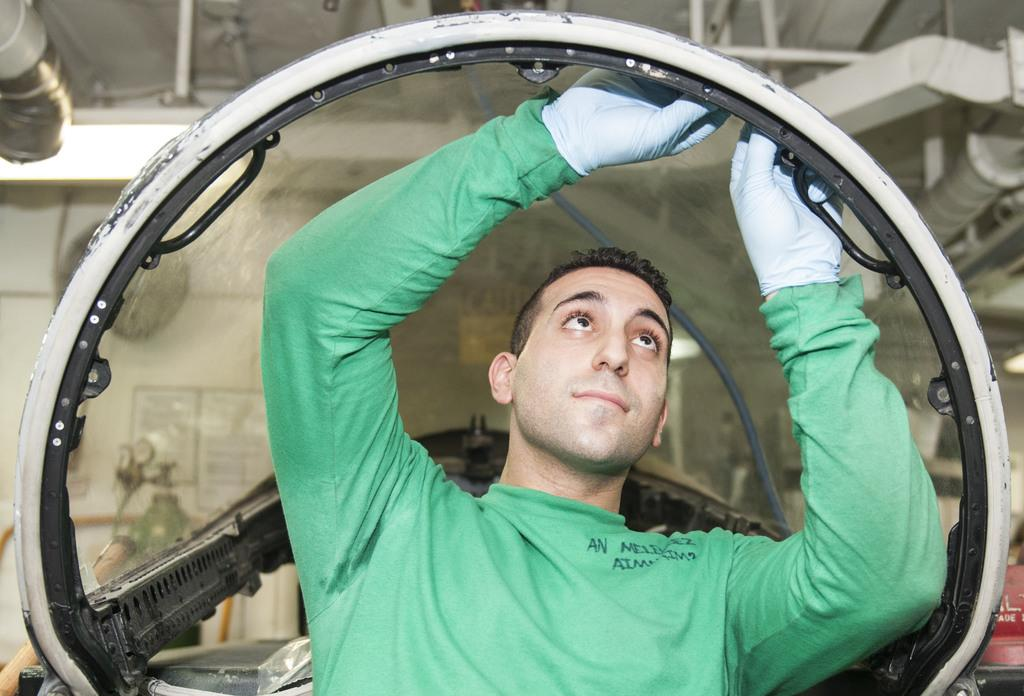What is the main subject of the image? There is a man standing in the center of the image. What is the man holding in the image? The man is holding a tube. What can be seen in the background of the image? There is a wall in the background of the image. What is present on the wall in the background? Pipes are visible at the top of the wall in the background. What type of badge is the man wearing on his shirt in the image? There is no badge visible on the man's shirt in the image. Can you tell me how the river flows in the image? There is no river present in the image; it features a man holding a tube and a wall with pipes in the background. 